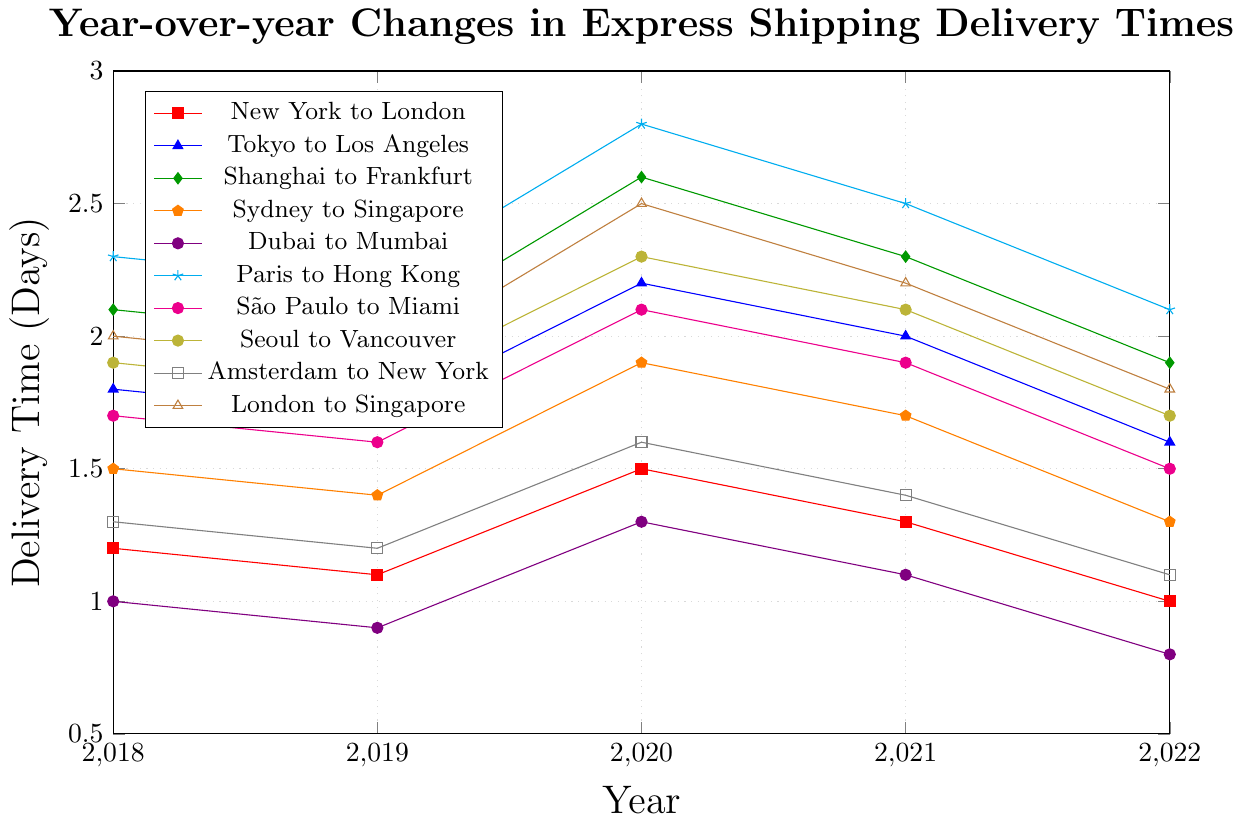What is the delivery time trend for the Tokyo to Los Angeles route between 2018 and 2022? The delivery time for the Tokyo to Los Angeles route starts at 1.8 days in 2018, decreases to 1.7 days in 2019, increases to 2.2 days in 2020, slightly decreases to 2.0 days in 2021, and finally decreases to 1.6 days in 2022.
Answer: Decreasing trend Which route experienced the highest increase in delivery time in 2020 compared to 2019? To find this, we need to calculate the difference between the delivery times of 2020 and 2019 for each route. Shanghai to Frankfurt has the highest increase of 0.6 days (2.6 - 2.0).
Answer: Shanghai to Frankfurt For the route New York to London, what is the average delivery time over these years? To find the average, sum the delivery times from 2018 to 2022 and divide by the number of years: (1.2 + 1.1 + 1.5 + 1.3 + 1.0) / 5 = 6.1 / 5.
Answer: 1.22 days Between 2018 and 2022, which year had the highest overall delivery time for the São Paulo to Miami route? According to the figure, the delivery times for São Paulo to Miami over these years are 1.7, 1.6, 2.1, 1.9, and 1.5. The highest value is 2.1, observed in 2020.
Answer: 2020 How does the 2022 delivery time for London to Singapore compare to the 2022 delivery time for Paris to Hong Kong? The figure shows that the delivery time for London to Singapore in 2022 is 1.8 days and for Paris to Hong Kong, it is 2.1 days.
Answer: London to Singapore is shorter Which route shows the most consistent delivery time across the years from 2018 to 2022? Consistency can be observed via minor changes in values over the years. The New York to London route varies only between 1.0 and 1.5, making it the most consistent.
Answer: New York to London Calculate the total sum of delivery times for Dubai to Mumbai between 2018 and 2022. Sum the individual delivery times for each year: 1.0 + 0.9 + 1.3 + 1.1 + 0.8 = 5.1 days.
Answer: 5.1 days In which year did the Sydney to Singapore route have its lowest delivery time? Inspecting the figure, the delivery times in 2022 for Sydney to Singapore is 1.3 days, which is the lowest compared to other years mentioned.
Answer: 2022 Identify the route with the highest delivery time in 2021 and specify the value. The route with the highest delivery time in 2021 is Paris to Hong Kong with a delivery time of 2.5 days.
Answer: Paris to Hong Kong, 2.5 days By how much did the delivery time for Amsterdam to New York decrease from 2020 to 2022? The delivery time for Amsterdam to New York in 2020 is 1.6 days and in 2022 is 1.1 days. The decrease is 1.6 - 1.1 = 0.5 days.
Answer: 0.5 days 